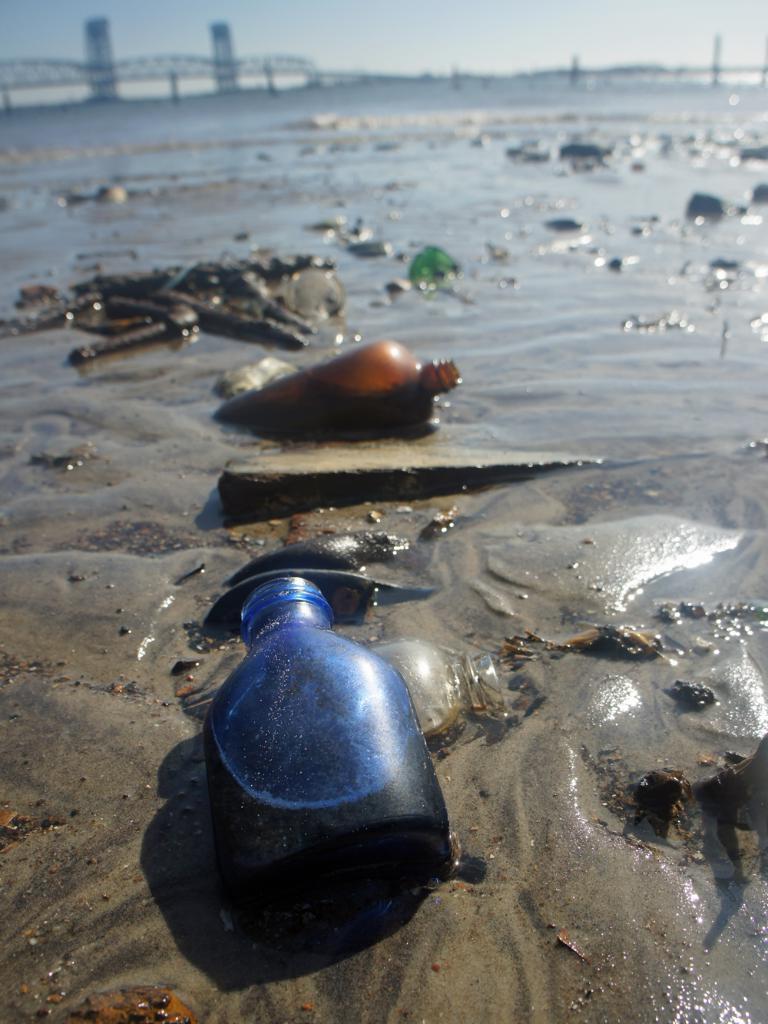Please provide a concise description of this image. In the picture we can see the sand with water with different bottles and dirt mud,far away we can see a bridge,here we can also see the sky. 